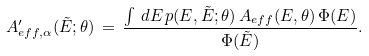Convert formula to latex. <formula><loc_0><loc_0><loc_500><loc_500>A _ { e f f , \alpha } ^ { \prime } ( \tilde { E } ; \theta ) \, = \, \frac { \int \, d E \, p ( E , \tilde { E } ; \theta ) \, A _ { e f f } ( E , \theta ) \, \Phi ( E ) } { \Phi ( \tilde { E } ) } .</formula> 